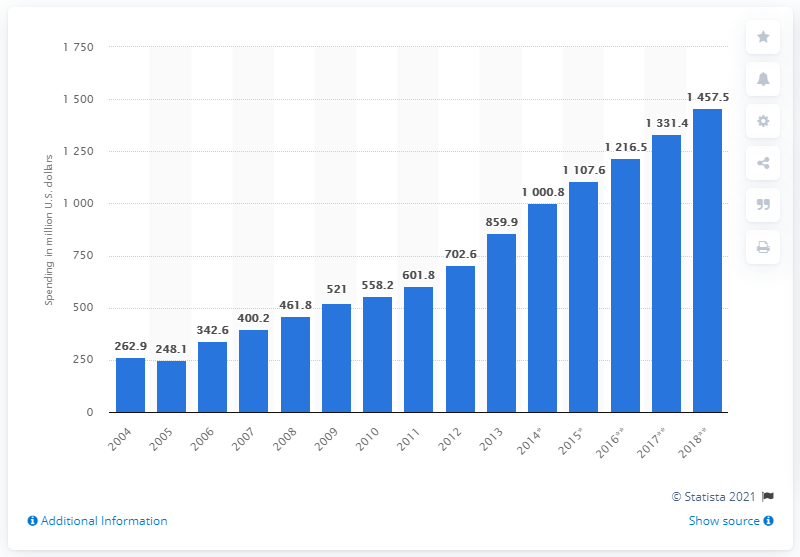What was the estimated ad expenditure in Vietnam in 2016?
 1216.5 